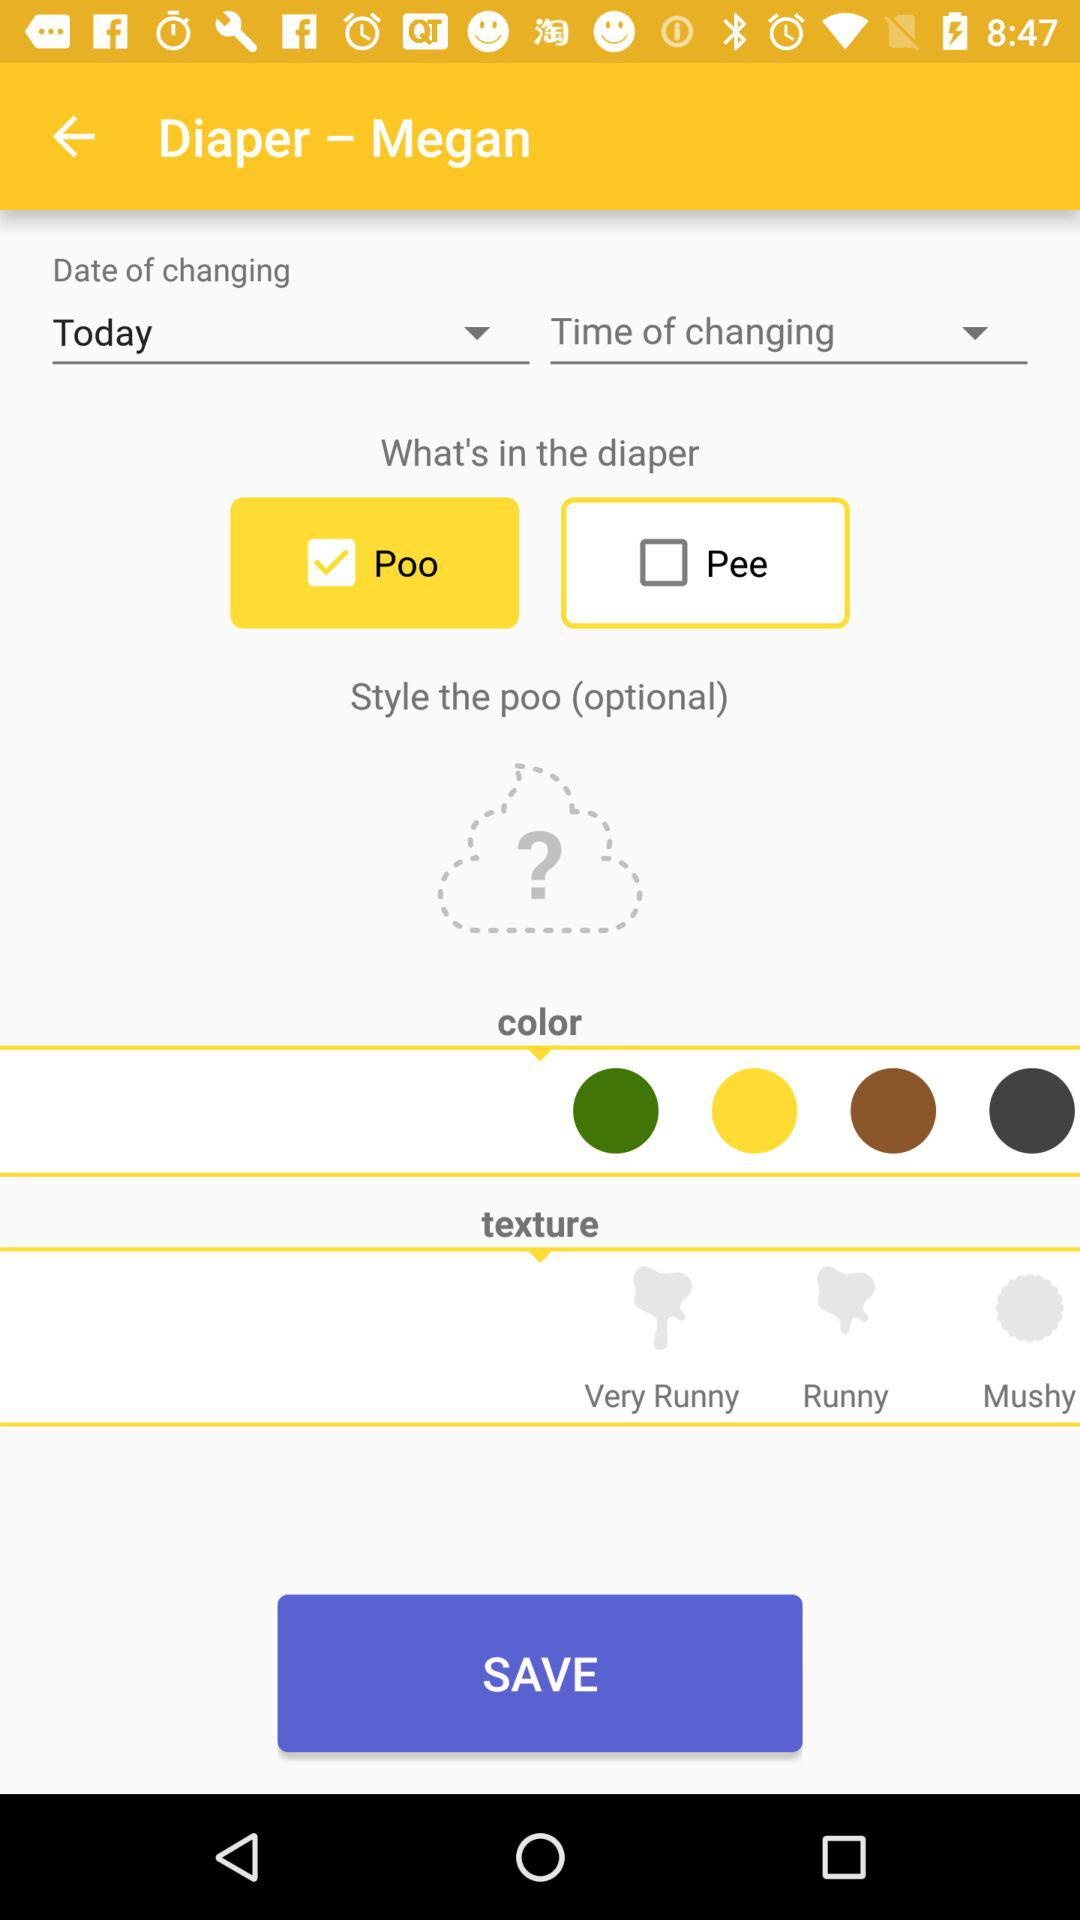Which option is selected for "Date of changing"? The selected option is "Today". 